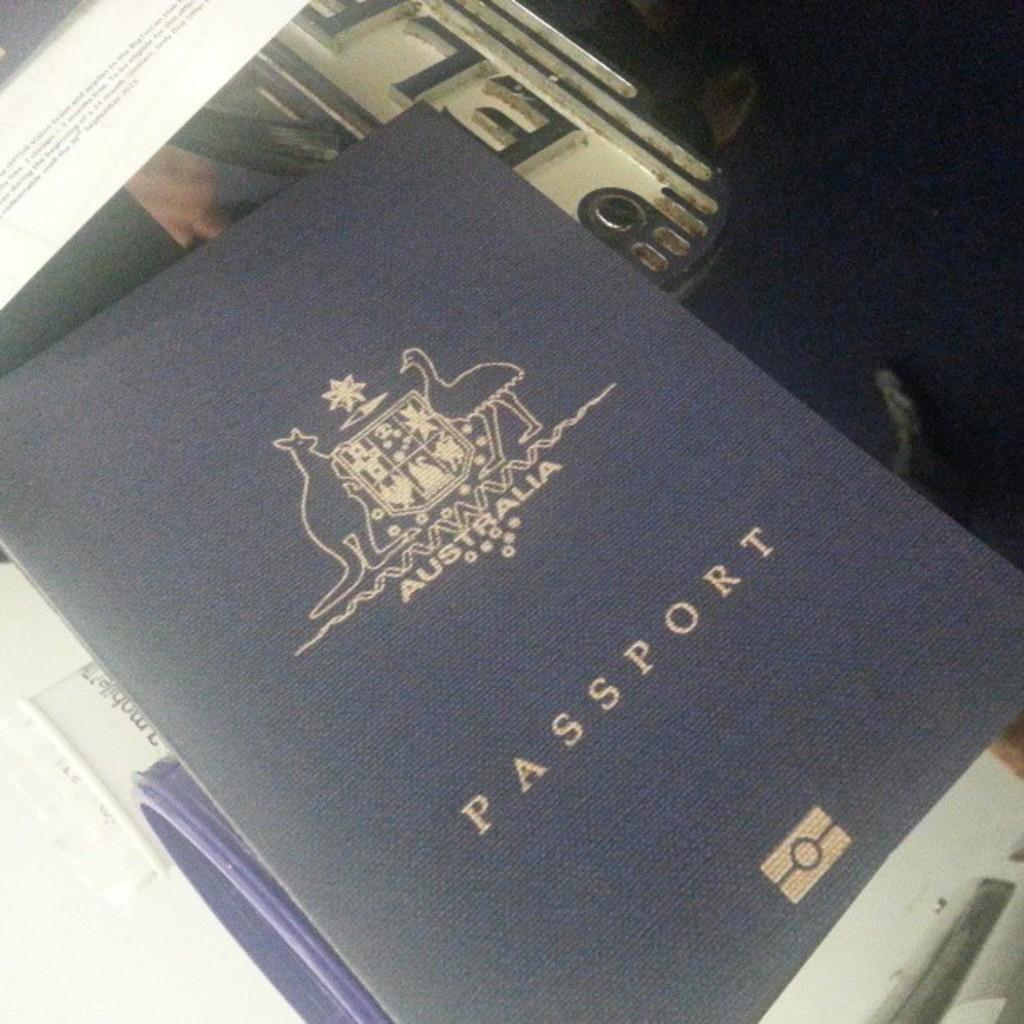<image>
Present a compact description of the photo's key features. Blue Passport on top of some other items. 